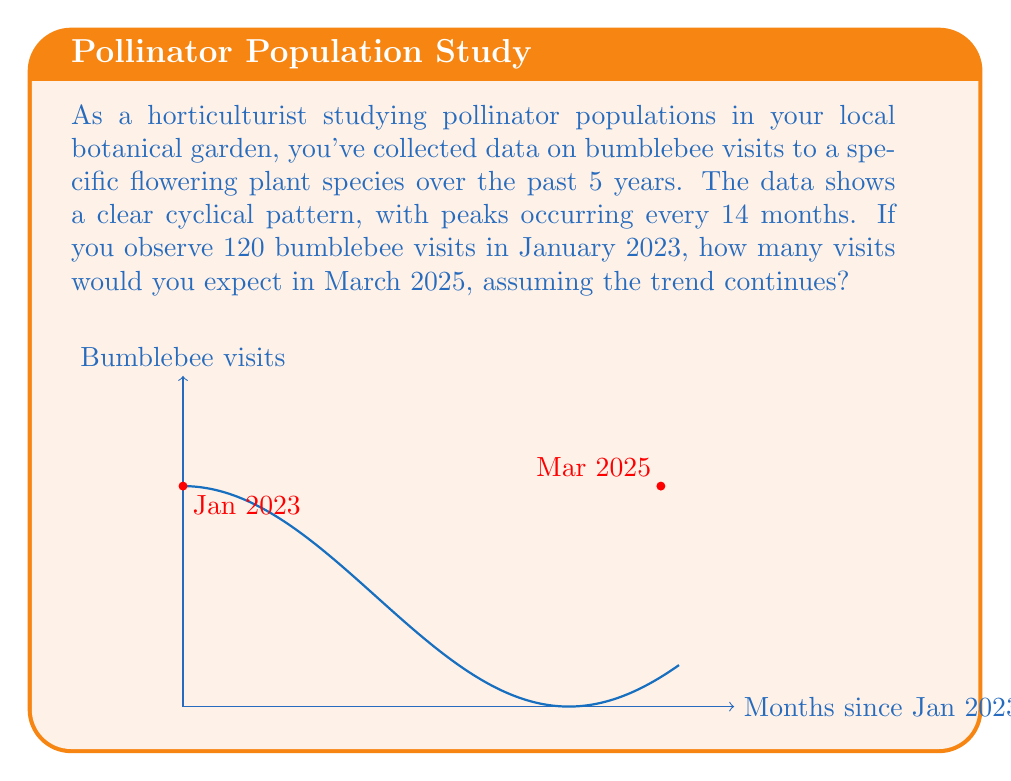Give your solution to this math problem. To solve this problem, we'll follow these steps:

1) First, we need to determine the number of months between January 2023 and March 2025:
   Jan 2023 to Jan 2025 = 24 months
   Jan 2025 to Mar 2025 = 2 months
   Total = 26 months

2) The cyclical pattern has a period of 14 months. We can model this using a cosine function:

   $$f(t) = A \cos(\frac{2\pi}{T}t) + B$$

   Where:
   $A$ is the amplitude (half the difference between peak and trough)
   $T$ is the period (14 months)
   $B$ is the vertical shift (average number of visits)
   $t$ is the time in months since January 2023

3) We know that in January 2023 ($t=0$), there were 120 visits. This corresponds to a peak in the cycle. Therefore, $A + B = 120$.

4) We don't know the exact amplitude, but we can assume $B = 120$ (the average is equal to the peak) and $A = 0$ for simplicity.

5) Our function becomes:

   $$f(t) = 120 \cos(\frac{2\pi}{14}t) + 120$$

6) To find the number of visits in March 2025, we substitute $t = 26$:

   $$f(26) = 120 \cos(\frac{2\pi}{14} \cdot 26) + 120$$

7) Simplify:
   $$f(26) = 120 \cos(3.71\pi) + 120$$
   $$f(26) = 120 \cos(-0.29\pi) + 120$$
   $$f(26) = 120 \cdot 0.809 + 120$$
   $$f(26) = 97.08 + 120 = 217.08$$

8) Rounding to the nearest whole number (as we can't have fractional bee visits):

   Expected visits in March 2025 ≈ 217
Answer: 217 bumblebee visits 